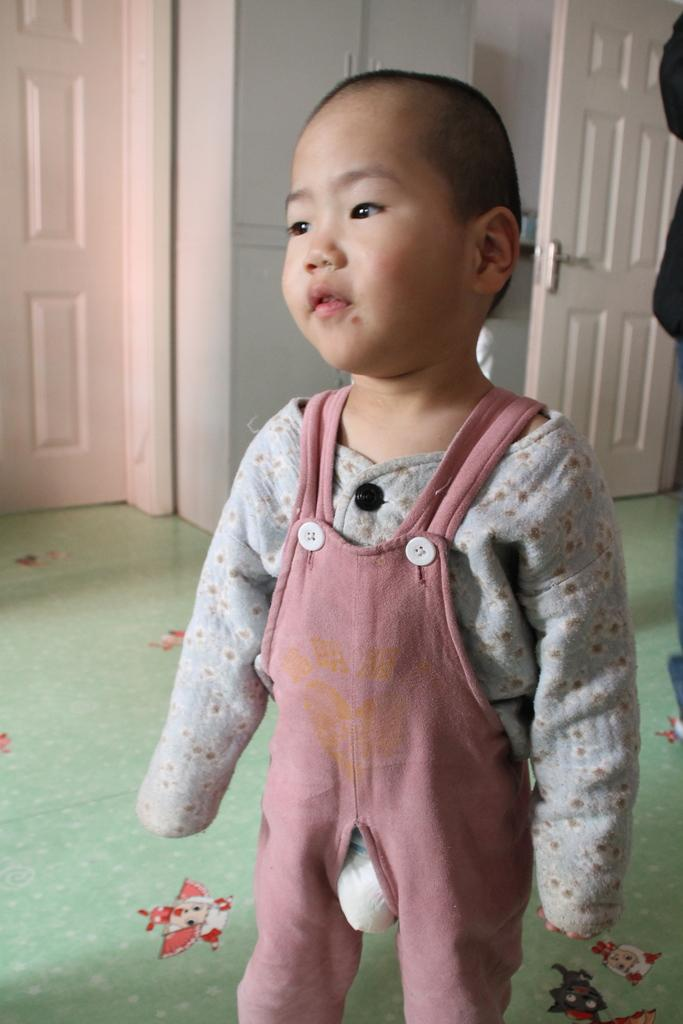What is the main subject of the image? There is a boy standing in the image. Can you describe the background of the image? There are doors visible in the background of the image. How many kittens are sitting on the scarecrow in the image? There is no scarecrow or kittens present in the image. 